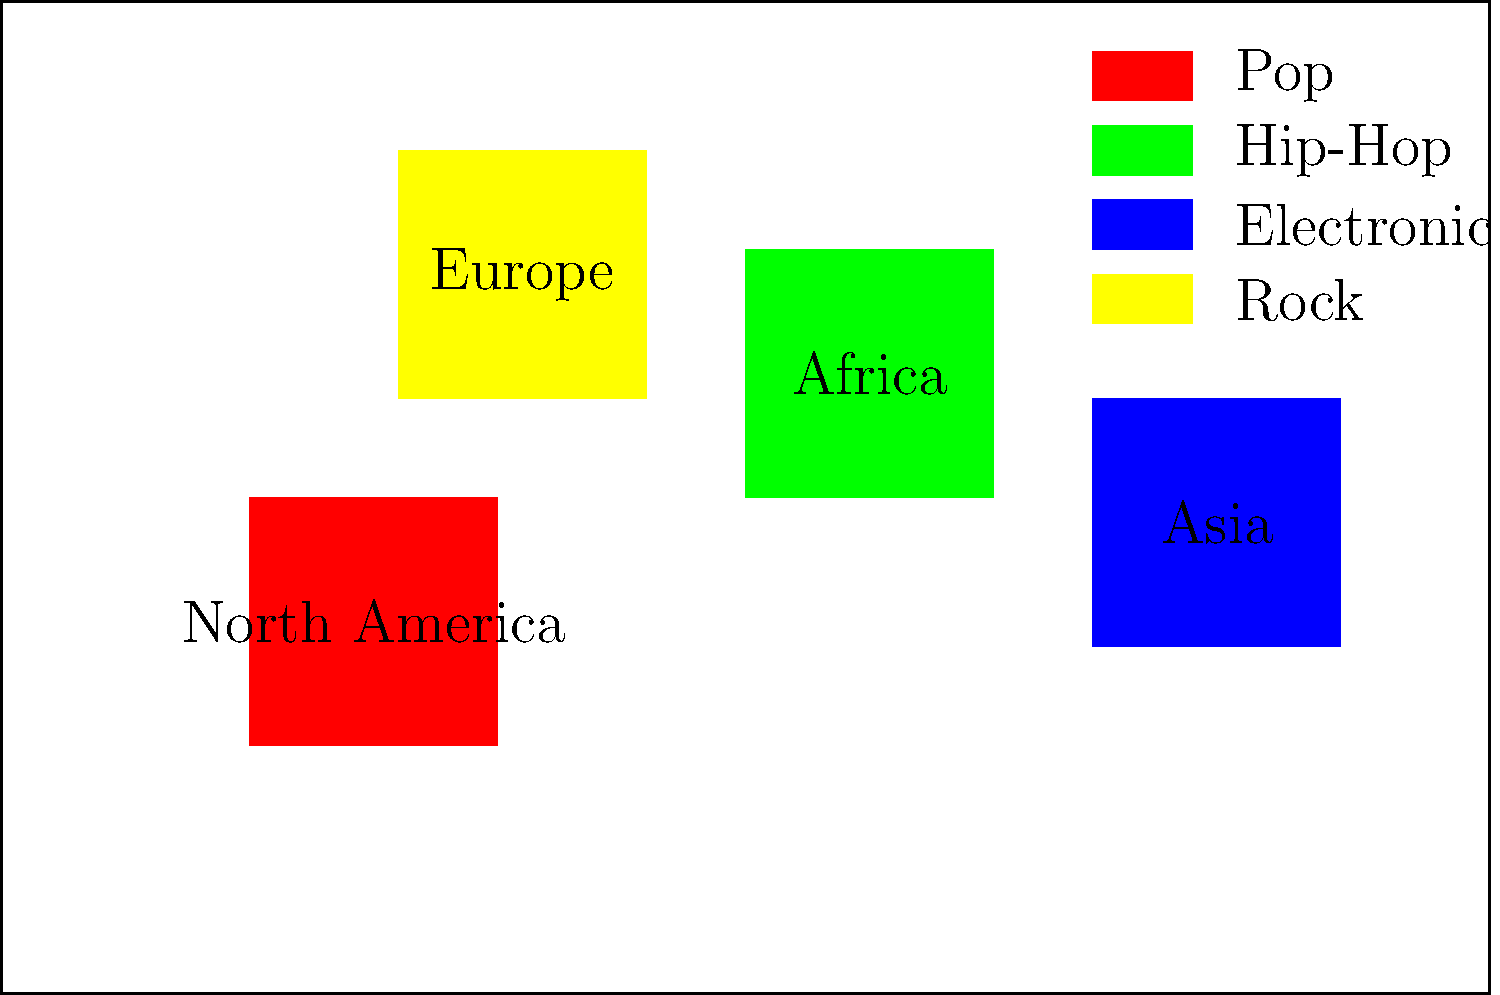Based on the world map showing the distribution of music genre popularity, which genre appears to be most dominant in North America? To determine the most dominant genre in North America, we need to follow these steps:

1. Identify the region representing North America on the map.
   - North America is labeled and located in the upper left quadrant of the map.

2. Observe the color of the region covering North America.
   - The region is filled with a red color.

3. Refer to the legend to match the color with the corresponding genre.
   - In the legend, we can see that the red color corresponds to "Pop" music.

4. Compare this with other regions to ensure it's the most dominant.
   - Other regions are colored differently, representing other genres.

Therefore, based on the color-coding and legend provided in the map, Pop music appears to be the most dominant genre in North America.
Answer: Pop 